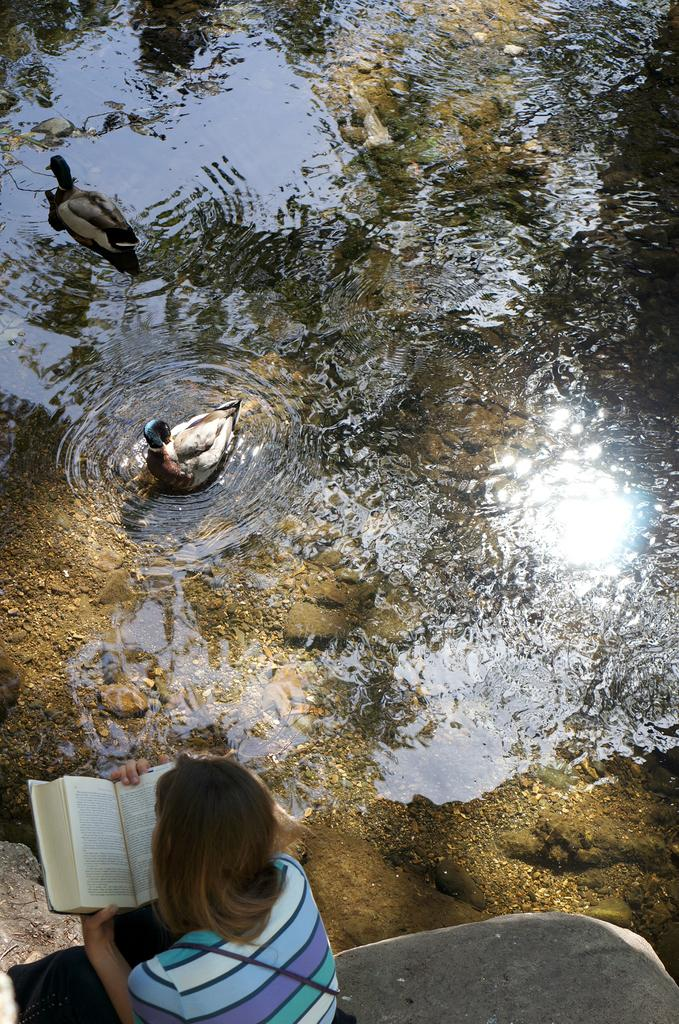What is the woman in the image doing? The woman is sitting at the bottom of the image and holding a book. What is the woman holding in her hands? The woman is holding a book. What can be seen in the middle of the image? There is water in the middle of the image. What is happening above the water in the image? Two ducks are swimming above the water. What type of grass is growing on the woman's head in the image? There is no grass growing on the woman's head in the image. 